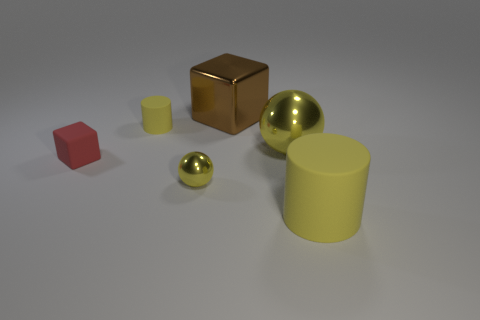What number of balls have the same size as the metal block? After observing the image, it appears that there is one ball that seems to match the size of the metal block. The comparison suggests that these two objects are of similar dimensions when viewed from the given perspective. 